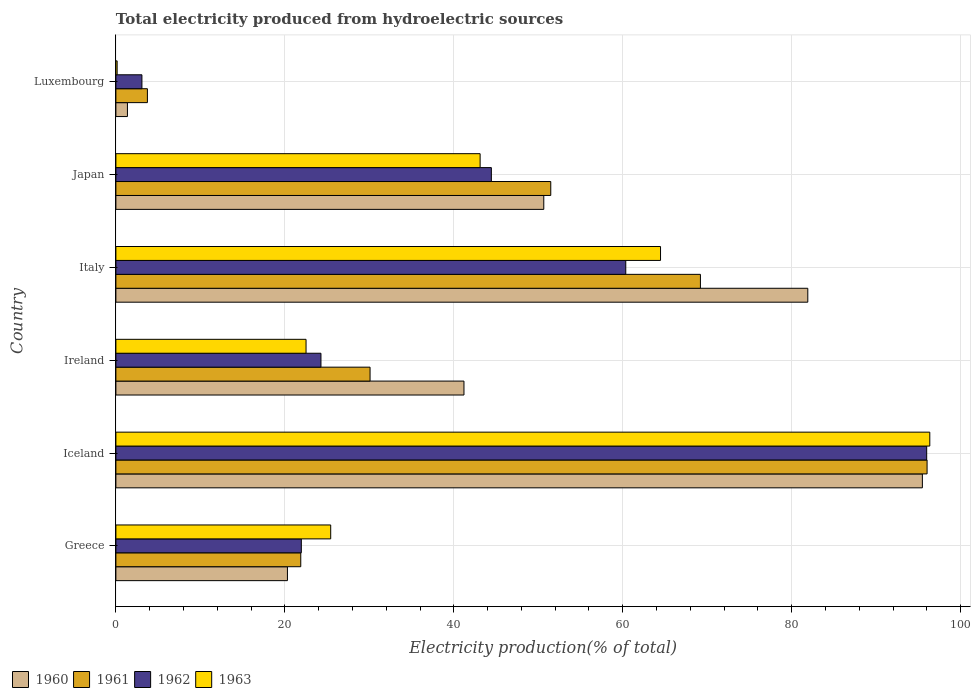How many different coloured bars are there?
Provide a succinct answer. 4. How many groups of bars are there?
Offer a terse response. 6. Are the number of bars per tick equal to the number of legend labels?
Keep it short and to the point. Yes. How many bars are there on the 1st tick from the bottom?
Provide a short and direct response. 4. What is the total electricity produced in 1961 in Iceland?
Your answer should be compact. 96.02. Across all countries, what is the maximum total electricity produced in 1961?
Your answer should be very brief. 96.02. Across all countries, what is the minimum total electricity produced in 1963?
Keep it short and to the point. 0.15. In which country was the total electricity produced in 1963 maximum?
Your response must be concise. Iceland. In which country was the total electricity produced in 1962 minimum?
Your response must be concise. Luxembourg. What is the total total electricity produced in 1960 in the graph?
Offer a terse response. 290.89. What is the difference between the total electricity produced in 1963 in Iceland and that in Ireland?
Ensure brevity in your answer.  73.83. What is the difference between the total electricity produced in 1961 in Ireland and the total electricity produced in 1963 in Greece?
Offer a terse response. 4.66. What is the average total electricity produced in 1963 per country?
Your answer should be compact. 42. What is the difference between the total electricity produced in 1963 and total electricity produced in 1960 in Luxembourg?
Ensure brevity in your answer.  -1.22. What is the ratio of the total electricity produced in 1963 in Greece to that in Iceland?
Offer a very short reply. 0.26. Is the difference between the total electricity produced in 1963 in Greece and Italy greater than the difference between the total electricity produced in 1960 in Greece and Italy?
Provide a succinct answer. Yes. What is the difference between the highest and the second highest total electricity produced in 1960?
Offer a very short reply. 13.56. What is the difference between the highest and the lowest total electricity produced in 1960?
Give a very brief answer. 94.1. Is the sum of the total electricity produced in 1962 in Greece and Ireland greater than the maximum total electricity produced in 1961 across all countries?
Give a very brief answer. No. Is it the case that in every country, the sum of the total electricity produced in 1963 and total electricity produced in 1962 is greater than the sum of total electricity produced in 1960 and total electricity produced in 1961?
Make the answer very short. No. Is it the case that in every country, the sum of the total electricity produced in 1962 and total electricity produced in 1960 is greater than the total electricity produced in 1963?
Make the answer very short. Yes. Are all the bars in the graph horizontal?
Provide a succinct answer. Yes. How many countries are there in the graph?
Your answer should be compact. 6. What is the difference between two consecutive major ticks on the X-axis?
Provide a short and direct response. 20. Does the graph contain any zero values?
Keep it short and to the point. No. How are the legend labels stacked?
Ensure brevity in your answer.  Horizontal. What is the title of the graph?
Offer a terse response. Total electricity produced from hydroelectric sources. What is the label or title of the X-axis?
Offer a very short reply. Electricity production(% of total). What is the Electricity production(% of total) in 1960 in Greece?
Give a very brief answer. 20.31. What is the Electricity production(% of total) in 1961 in Greece?
Provide a succinct answer. 21.88. What is the Electricity production(% of total) of 1962 in Greece?
Offer a terse response. 21.95. What is the Electricity production(% of total) in 1963 in Greece?
Ensure brevity in your answer.  25.43. What is the Electricity production(% of total) in 1960 in Iceland?
Make the answer very short. 95.46. What is the Electricity production(% of total) in 1961 in Iceland?
Make the answer very short. 96.02. What is the Electricity production(% of total) in 1962 in Iceland?
Give a very brief answer. 95.97. What is the Electricity production(% of total) in 1963 in Iceland?
Your response must be concise. 96.34. What is the Electricity production(% of total) of 1960 in Ireland?
Offer a very short reply. 41.2. What is the Electricity production(% of total) of 1961 in Ireland?
Ensure brevity in your answer.  30.09. What is the Electricity production(% of total) of 1962 in Ireland?
Give a very brief answer. 24.27. What is the Electricity production(% of total) in 1963 in Ireland?
Provide a succinct answer. 22.51. What is the Electricity production(% of total) in 1960 in Italy?
Your answer should be compact. 81.9. What is the Electricity production(% of total) of 1961 in Italy?
Provide a short and direct response. 69.19. What is the Electricity production(% of total) of 1962 in Italy?
Offer a terse response. 60.35. What is the Electricity production(% of total) of 1963 in Italy?
Offer a terse response. 64.47. What is the Electricity production(% of total) of 1960 in Japan?
Your answer should be compact. 50.65. What is the Electricity production(% of total) of 1961 in Japan?
Your answer should be very brief. 51.48. What is the Electricity production(% of total) in 1962 in Japan?
Give a very brief answer. 44.44. What is the Electricity production(% of total) of 1963 in Japan?
Your response must be concise. 43.11. What is the Electricity production(% of total) in 1960 in Luxembourg?
Give a very brief answer. 1.37. What is the Electricity production(% of total) of 1961 in Luxembourg?
Give a very brief answer. 3.73. What is the Electricity production(% of total) of 1962 in Luxembourg?
Make the answer very short. 3.08. What is the Electricity production(% of total) in 1963 in Luxembourg?
Make the answer very short. 0.15. Across all countries, what is the maximum Electricity production(% of total) in 1960?
Provide a succinct answer. 95.46. Across all countries, what is the maximum Electricity production(% of total) in 1961?
Make the answer very short. 96.02. Across all countries, what is the maximum Electricity production(% of total) in 1962?
Your answer should be compact. 95.97. Across all countries, what is the maximum Electricity production(% of total) in 1963?
Your answer should be very brief. 96.34. Across all countries, what is the minimum Electricity production(% of total) of 1960?
Make the answer very short. 1.37. Across all countries, what is the minimum Electricity production(% of total) of 1961?
Give a very brief answer. 3.73. Across all countries, what is the minimum Electricity production(% of total) in 1962?
Your answer should be compact. 3.08. Across all countries, what is the minimum Electricity production(% of total) in 1963?
Provide a succinct answer. 0.15. What is the total Electricity production(% of total) in 1960 in the graph?
Provide a succinct answer. 290.89. What is the total Electricity production(% of total) of 1961 in the graph?
Keep it short and to the point. 272.39. What is the total Electricity production(% of total) in 1962 in the graph?
Provide a short and direct response. 250.08. What is the total Electricity production(% of total) of 1963 in the graph?
Give a very brief answer. 252.01. What is the difference between the Electricity production(% of total) of 1960 in Greece and that in Iceland?
Keep it short and to the point. -75.16. What is the difference between the Electricity production(% of total) in 1961 in Greece and that in Iceland?
Your response must be concise. -74.14. What is the difference between the Electricity production(% of total) of 1962 in Greece and that in Iceland?
Offer a very short reply. -74.02. What is the difference between the Electricity production(% of total) in 1963 in Greece and that in Iceland?
Your response must be concise. -70.91. What is the difference between the Electricity production(% of total) of 1960 in Greece and that in Ireland?
Keep it short and to the point. -20.9. What is the difference between the Electricity production(% of total) of 1961 in Greece and that in Ireland?
Your answer should be very brief. -8.2. What is the difference between the Electricity production(% of total) of 1962 in Greece and that in Ireland?
Make the answer very short. -2.32. What is the difference between the Electricity production(% of total) of 1963 in Greece and that in Ireland?
Provide a short and direct response. 2.92. What is the difference between the Electricity production(% of total) of 1960 in Greece and that in Italy?
Offer a very short reply. -61.59. What is the difference between the Electricity production(% of total) of 1961 in Greece and that in Italy?
Your answer should be very brief. -47.31. What is the difference between the Electricity production(% of total) in 1962 in Greece and that in Italy?
Keep it short and to the point. -38.4. What is the difference between the Electricity production(% of total) of 1963 in Greece and that in Italy?
Ensure brevity in your answer.  -39.04. What is the difference between the Electricity production(% of total) in 1960 in Greece and that in Japan?
Offer a very short reply. -30.34. What is the difference between the Electricity production(% of total) in 1961 in Greece and that in Japan?
Offer a very short reply. -29.59. What is the difference between the Electricity production(% of total) in 1962 in Greece and that in Japan?
Keep it short and to the point. -22.49. What is the difference between the Electricity production(% of total) in 1963 in Greece and that in Japan?
Give a very brief answer. -17.69. What is the difference between the Electricity production(% of total) of 1960 in Greece and that in Luxembourg?
Offer a very short reply. 18.94. What is the difference between the Electricity production(% of total) of 1961 in Greece and that in Luxembourg?
Your answer should be very brief. 18.15. What is the difference between the Electricity production(% of total) of 1962 in Greece and that in Luxembourg?
Your answer should be very brief. 18.87. What is the difference between the Electricity production(% of total) of 1963 in Greece and that in Luxembourg?
Provide a short and direct response. 25.28. What is the difference between the Electricity production(% of total) of 1960 in Iceland and that in Ireland?
Your answer should be very brief. 54.26. What is the difference between the Electricity production(% of total) in 1961 in Iceland and that in Ireland?
Your answer should be compact. 65.93. What is the difference between the Electricity production(% of total) in 1962 in Iceland and that in Ireland?
Offer a terse response. 71.7. What is the difference between the Electricity production(% of total) in 1963 in Iceland and that in Ireland?
Your response must be concise. 73.83. What is the difference between the Electricity production(% of total) of 1960 in Iceland and that in Italy?
Your answer should be very brief. 13.56. What is the difference between the Electricity production(% of total) of 1961 in Iceland and that in Italy?
Ensure brevity in your answer.  26.83. What is the difference between the Electricity production(% of total) in 1962 in Iceland and that in Italy?
Your answer should be very brief. 35.62. What is the difference between the Electricity production(% of total) of 1963 in Iceland and that in Italy?
Offer a terse response. 31.87. What is the difference between the Electricity production(% of total) of 1960 in Iceland and that in Japan?
Give a very brief answer. 44.81. What is the difference between the Electricity production(% of total) in 1961 in Iceland and that in Japan?
Offer a terse response. 44.54. What is the difference between the Electricity production(% of total) in 1962 in Iceland and that in Japan?
Your answer should be very brief. 51.53. What is the difference between the Electricity production(% of total) in 1963 in Iceland and that in Japan?
Offer a very short reply. 53.23. What is the difference between the Electricity production(% of total) in 1960 in Iceland and that in Luxembourg?
Offer a very short reply. 94.1. What is the difference between the Electricity production(% of total) in 1961 in Iceland and that in Luxembourg?
Keep it short and to the point. 92.29. What is the difference between the Electricity production(% of total) in 1962 in Iceland and that in Luxembourg?
Offer a very short reply. 92.89. What is the difference between the Electricity production(% of total) of 1963 in Iceland and that in Luxembourg?
Keep it short and to the point. 96.19. What is the difference between the Electricity production(% of total) of 1960 in Ireland and that in Italy?
Keep it short and to the point. -40.7. What is the difference between the Electricity production(% of total) of 1961 in Ireland and that in Italy?
Your answer should be very brief. -39.1. What is the difference between the Electricity production(% of total) of 1962 in Ireland and that in Italy?
Ensure brevity in your answer.  -36.08. What is the difference between the Electricity production(% of total) in 1963 in Ireland and that in Italy?
Your answer should be compact. -41.96. What is the difference between the Electricity production(% of total) of 1960 in Ireland and that in Japan?
Your response must be concise. -9.45. What is the difference between the Electricity production(% of total) of 1961 in Ireland and that in Japan?
Keep it short and to the point. -21.39. What is the difference between the Electricity production(% of total) in 1962 in Ireland and that in Japan?
Your response must be concise. -20.17. What is the difference between the Electricity production(% of total) of 1963 in Ireland and that in Japan?
Provide a succinct answer. -20.61. What is the difference between the Electricity production(% of total) of 1960 in Ireland and that in Luxembourg?
Offer a terse response. 39.84. What is the difference between the Electricity production(% of total) in 1961 in Ireland and that in Luxembourg?
Make the answer very short. 26.36. What is the difference between the Electricity production(% of total) of 1962 in Ireland and that in Luxembourg?
Offer a terse response. 21.19. What is the difference between the Electricity production(% of total) of 1963 in Ireland and that in Luxembourg?
Give a very brief answer. 22.36. What is the difference between the Electricity production(% of total) in 1960 in Italy and that in Japan?
Offer a very short reply. 31.25. What is the difference between the Electricity production(% of total) in 1961 in Italy and that in Japan?
Offer a terse response. 17.71. What is the difference between the Electricity production(% of total) in 1962 in Italy and that in Japan?
Provide a short and direct response. 15.91. What is the difference between the Electricity production(% of total) in 1963 in Italy and that in Japan?
Offer a very short reply. 21.35. What is the difference between the Electricity production(% of total) in 1960 in Italy and that in Luxembourg?
Offer a very short reply. 80.53. What is the difference between the Electricity production(% of total) in 1961 in Italy and that in Luxembourg?
Your answer should be very brief. 65.46. What is the difference between the Electricity production(% of total) in 1962 in Italy and that in Luxembourg?
Make the answer very short. 57.27. What is the difference between the Electricity production(% of total) of 1963 in Italy and that in Luxembourg?
Provide a succinct answer. 64.32. What is the difference between the Electricity production(% of total) of 1960 in Japan and that in Luxembourg?
Offer a terse response. 49.28. What is the difference between the Electricity production(% of total) of 1961 in Japan and that in Luxembourg?
Provide a short and direct response. 47.75. What is the difference between the Electricity production(% of total) of 1962 in Japan and that in Luxembourg?
Offer a very short reply. 41.36. What is the difference between the Electricity production(% of total) of 1963 in Japan and that in Luxembourg?
Provide a succinct answer. 42.97. What is the difference between the Electricity production(% of total) in 1960 in Greece and the Electricity production(% of total) in 1961 in Iceland?
Offer a terse response. -75.71. What is the difference between the Electricity production(% of total) in 1960 in Greece and the Electricity production(% of total) in 1962 in Iceland?
Ensure brevity in your answer.  -75.67. What is the difference between the Electricity production(% of total) of 1960 in Greece and the Electricity production(% of total) of 1963 in Iceland?
Offer a terse response. -76.04. What is the difference between the Electricity production(% of total) of 1961 in Greece and the Electricity production(% of total) of 1962 in Iceland?
Offer a very short reply. -74.09. What is the difference between the Electricity production(% of total) of 1961 in Greece and the Electricity production(% of total) of 1963 in Iceland?
Your answer should be very brief. -74.46. What is the difference between the Electricity production(% of total) of 1962 in Greece and the Electricity production(% of total) of 1963 in Iceland?
Your answer should be compact. -74.39. What is the difference between the Electricity production(% of total) in 1960 in Greece and the Electricity production(% of total) in 1961 in Ireland?
Provide a succinct answer. -9.78. What is the difference between the Electricity production(% of total) in 1960 in Greece and the Electricity production(% of total) in 1962 in Ireland?
Ensure brevity in your answer.  -3.97. What is the difference between the Electricity production(% of total) in 1960 in Greece and the Electricity production(% of total) in 1963 in Ireland?
Keep it short and to the point. -2.2. What is the difference between the Electricity production(% of total) of 1961 in Greece and the Electricity production(% of total) of 1962 in Ireland?
Ensure brevity in your answer.  -2.39. What is the difference between the Electricity production(% of total) in 1961 in Greece and the Electricity production(% of total) in 1963 in Ireland?
Give a very brief answer. -0.63. What is the difference between the Electricity production(% of total) in 1962 in Greece and the Electricity production(% of total) in 1963 in Ireland?
Keep it short and to the point. -0.56. What is the difference between the Electricity production(% of total) in 1960 in Greece and the Electricity production(% of total) in 1961 in Italy?
Your answer should be compact. -48.88. What is the difference between the Electricity production(% of total) of 1960 in Greece and the Electricity production(% of total) of 1962 in Italy?
Ensure brevity in your answer.  -40.05. What is the difference between the Electricity production(% of total) in 1960 in Greece and the Electricity production(% of total) in 1963 in Italy?
Offer a terse response. -44.16. What is the difference between the Electricity production(% of total) in 1961 in Greece and the Electricity production(% of total) in 1962 in Italy?
Your answer should be very brief. -38.47. What is the difference between the Electricity production(% of total) in 1961 in Greece and the Electricity production(% of total) in 1963 in Italy?
Your response must be concise. -42.58. What is the difference between the Electricity production(% of total) in 1962 in Greece and the Electricity production(% of total) in 1963 in Italy?
Keep it short and to the point. -42.52. What is the difference between the Electricity production(% of total) of 1960 in Greece and the Electricity production(% of total) of 1961 in Japan?
Your answer should be compact. -31.17. What is the difference between the Electricity production(% of total) in 1960 in Greece and the Electricity production(% of total) in 1962 in Japan?
Your answer should be very brief. -24.14. What is the difference between the Electricity production(% of total) in 1960 in Greece and the Electricity production(% of total) in 1963 in Japan?
Your answer should be compact. -22.81. What is the difference between the Electricity production(% of total) of 1961 in Greece and the Electricity production(% of total) of 1962 in Japan?
Your response must be concise. -22.56. What is the difference between the Electricity production(% of total) in 1961 in Greece and the Electricity production(% of total) in 1963 in Japan?
Provide a succinct answer. -21.23. What is the difference between the Electricity production(% of total) in 1962 in Greece and the Electricity production(% of total) in 1963 in Japan?
Keep it short and to the point. -21.16. What is the difference between the Electricity production(% of total) of 1960 in Greece and the Electricity production(% of total) of 1961 in Luxembourg?
Ensure brevity in your answer.  16.58. What is the difference between the Electricity production(% of total) of 1960 in Greece and the Electricity production(% of total) of 1962 in Luxembourg?
Give a very brief answer. 17.22. What is the difference between the Electricity production(% of total) of 1960 in Greece and the Electricity production(% of total) of 1963 in Luxembourg?
Offer a terse response. 20.16. What is the difference between the Electricity production(% of total) of 1961 in Greece and the Electricity production(% of total) of 1962 in Luxembourg?
Keep it short and to the point. 18.8. What is the difference between the Electricity production(% of total) in 1961 in Greece and the Electricity production(% of total) in 1963 in Luxembourg?
Make the answer very short. 21.74. What is the difference between the Electricity production(% of total) of 1962 in Greece and the Electricity production(% of total) of 1963 in Luxembourg?
Ensure brevity in your answer.  21.8. What is the difference between the Electricity production(% of total) of 1960 in Iceland and the Electricity production(% of total) of 1961 in Ireland?
Keep it short and to the point. 65.38. What is the difference between the Electricity production(% of total) in 1960 in Iceland and the Electricity production(% of total) in 1962 in Ireland?
Keep it short and to the point. 71.19. What is the difference between the Electricity production(% of total) of 1960 in Iceland and the Electricity production(% of total) of 1963 in Ireland?
Your response must be concise. 72.95. What is the difference between the Electricity production(% of total) of 1961 in Iceland and the Electricity production(% of total) of 1962 in Ireland?
Offer a terse response. 71.75. What is the difference between the Electricity production(% of total) of 1961 in Iceland and the Electricity production(% of total) of 1963 in Ireland?
Make the answer very short. 73.51. What is the difference between the Electricity production(% of total) in 1962 in Iceland and the Electricity production(% of total) in 1963 in Ireland?
Offer a very short reply. 73.47. What is the difference between the Electricity production(% of total) of 1960 in Iceland and the Electricity production(% of total) of 1961 in Italy?
Make the answer very short. 26.27. What is the difference between the Electricity production(% of total) of 1960 in Iceland and the Electricity production(% of total) of 1962 in Italy?
Ensure brevity in your answer.  35.11. What is the difference between the Electricity production(% of total) in 1960 in Iceland and the Electricity production(% of total) in 1963 in Italy?
Provide a short and direct response. 30.99. What is the difference between the Electricity production(% of total) in 1961 in Iceland and the Electricity production(% of total) in 1962 in Italy?
Make the answer very short. 35.67. What is the difference between the Electricity production(% of total) in 1961 in Iceland and the Electricity production(% of total) in 1963 in Italy?
Provide a succinct answer. 31.55. What is the difference between the Electricity production(% of total) in 1962 in Iceland and the Electricity production(% of total) in 1963 in Italy?
Offer a terse response. 31.51. What is the difference between the Electricity production(% of total) of 1960 in Iceland and the Electricity production(% of total) of 1961 in Japan?
Your response must be concise. 43.99. What is the difference between the Electricity production(% of total) of 1960 in Iceland and the Electricity production(% of total) of 1962 in Japan?
Your response must be concise. 51.02. What is the difference between the Electricity production(% of total) in 1960 in Iceland and the Electricity production(% of total) in 1963 in Japan?
Ensure brevity in your answer.  52.35. What is the difference between the Electricity production(% of total) of 1961 in Iceland and the Electricity production(% of total) of 1962 in Japan?
Provide a succinct answer. 51.58. What is the difference between the Electricity production(% of total) in 1961 in Iceland and the Electricity production(% of total) in 1963 in Japan?
Your answer should be very brief. 52.91. What is the difference between the Electricity production(% of total) of 1962 in Iceland and the Electricity production(% of total) of 1963 in Japan?
Your response must be concise. 52.86. What is the difference between the Electricity production(% of total) in 1960 in Iceland and the Electricity production(% of total) in 1961 in Luxembourg?
Your answer should be compact. 91.73. What is the difference between the Electricity production(% of total) in 1960 in Iceland and the Electricity production(% of total) in 1962 in Luxembourg?
Provide a short and direct response. 92.38. What is the difference between the Electricity production(% of total) in 1960 in Iceland and the Electricity production(% of total) in 1963 in Luxembourg?
Give a very brief answer. 95.32. What is the difference between the Electricity production(% of total) of 1961 in Iceland and the Electricity production(% of total) of 1962 in Luxembourg?
Offer a terse response. 92.94. What is the difference between the Electricity production(% of total) of 1961 in Iceland and the Electricity production(% of total) of 1963 in Luxembourg?
Provide a succinct answer. 95.87. What is the difference between the Electricity production(% of total) of 1962 in Iceland and the Electricity production(% of total) of 1963 in Luxembourg?
Give a very brief answer. 95.83. What is the difference between the Electricity production(% of total) of 1960 in Ireland and the Electricity production(% of total) of 1961 in Italy?
Make the answer very short. -27.99. What is the difference between the Electricity production(% of total) in 1960 in Ireland and the Electricity production(% of total) in 1962 in Italy?
Provide a short and direct response. -19.15. What is the difference between the Electricity production(% of total) of 1960 in Ireland and the Electricity production(% of total) of 1963 in Italy?
Your response must be concise. -23.27. What is the difference between the Electricity production(% of total) in 1961 in Ireland and the Electricity production(% of total) in 1962 in Italy?
Keep it short and to the point. -30.27. What is the difference between the Electricity production(% of total) in 1961 in Ireland and the Electricity production(% of total) in 1963 in Italy?
Give a very brief answer. -34.38. What is the difference between the Electricity production(% of total) in 1962 in Ireland and the Electricity production(% of total) in 1963 in Italy?
Provide a succinct answer. -40.2. What is the difference between the Electricity production(% of total) of 1960 in Ireland and the Electricity production(% of total) of 1961 in Japan?
Your answer should be compact. -10.27. What is the difference between the Electricity production(% of total) of 1960 in Ireland and the Electricity production(% of total) of 1962 in Japan?
Your answer should be very brief. -3.24. What is the difference between the Electricity production(% of total) of 1960 in Ireland and the Electricity production(% of total) of 1963 in Japan?
Keep it short and to the point. -1.91. What is the difference between the Electricity production(% of total) in 1961 in Ireland and the Electricity production(% of total) in 1962 in Japan?
Provide a short and direct response. -14.36. What is the difference between the Electricity production(% of total) in 1961 in Ireland and the Electricity production(% of total) in 1963 in Japan?
Offer a very short reply. -13.03. What is the difference between the Electricity production(% of total) in 1962 in Ireland and the Electricity production(% of total) in 1963 in Japan?
Ensure brevity in your answer.  -18.84. What is the difference between the Electricity production(% of total) in 1960 in Ireland and the Electricity production(% of total) in 1961 in Luxembourg?
Offer a terse response. 37.47. What is the difference between the Electricity production(% of total) in 1960 in Ireland and the Electricity production(% of total) in 1962 in Luxembourg?
Your answer should be compact. 38.12. What is the difference between the Electricity production(% of total) in 1960 in Ireland and the Electricity production(% of total) in 1963 in Luxembourg?
Your answer should be very brief. 41.05. What is the difference between the Electricity production(% of total) in 1961 in Ireland and the Electricity production(% of total) in 1962 in Luxembourg?
Keep it short and to the point. 27. What is the difference between the Electricity production(% of total) of 1961 in Ireland and the Electricity production(% of total) of 1963 in Luxembourg?
Provide a succinct answer. 29.94. What is the difference between the Electricity production(% of total) of 1962 in Ireland and the Electricity production(% of total) of 1963 in Luxembourg?
Your response must be concise. 24.12. What is the difference between the Electricity production(% of total) of 1960 in Italy and the Electricity production(% of total) of 1961 in Japan?
Provide a short and direct response. 30.42. What is the difference between the Electricity production(% of total) of 1960 in Italy and the Electricity production(% of total) of 1962 in Japan?
Offer a terse response. 37.46. What is the difference between the Electricity production(% of total) of 1960 in Italy and the Electricity production(% of total) of 1963 in Japan?
Make the answer very short. 38.79. What is the difference between the Electricity production(% of total) of 1961 in Italy and the Electricity production(% of total) of 1962 in Japan?
Ensure brevity in your answer.  24.75. What is the difference between the Electricity production(% of total) in 1961 in Italy and the Electricity production(% of total) in 1963 in Japan?
Your response must be concise. 26.08. What is the difference between the Electricity production(% of total) of 1962 in Italy and the Electricity production(% of total) of 1963 in Japan?
Your answer should be compact. 17.24. What is the difference between the Electricity production(% of total) in 1960 in Italy and the Electricity production(% of total) in 1961 in Luxembourg?
Ensure brevity in your answer.  78.17. What is the difference between the Electricity production(% of total) in 1960 in Italy and the Electricity production(% of total) in 1962 in Luxembourg?
Offer a very short reply. 78.82. What is the difference between the Electricity production(% of total) of 1960 in Italy and the Electricity production(% of total) of 1963 in Luxembourg?
Offer a very short reply. 81.75. What is the difference between the Electricity production(% of total) in 1961 in Italy and the Electricity production(% of total) in 1962 in Luxembourg?
Your response must be concise. 66.11. What is the difference between the Electricity production(% of total) in 1961 in Italy and the Electricity production(% of total) in 1963 in Luxembourg?
Provide a short and direct response. 69.04. What is the difference between the Electricity production(% of total) of 1962 in Italy and the Electricity production(% of total) of 1963 in Luxembourg?
Provide a succinct answer. 60.21. What is the difference between the Electricity production(% of total) of 1960 in Japan and the Electricity production(% of total) of 1961 in Luxembourg?
Make the answer very short. 46.92. What is the difference between the Electricity production(% of total) of 1960 in Japan and the Electricity production(% of total) of 1962 in Luxembourg?
Your answer should be compact. 47.57. What is the difference between the Electricity production(% of total) in 1960 in Japan and the Electricity production(% of total) in 1963 in Luxembourg?
Offer a very short reply. 50.5. What is the difference between the Electricity production(% of total) of 1961 in Japan and the Electricity production(% of total) of 1962 in Luxembourg?
Provide a succinct answer. 48.39. What is the difference between the Electricity production(% of total) of 1961 in Japan and the Electricity production(% of total) of 1963 in Luxembourg?
Give a very brief answer. 51.33. What is the difference between the Electricity production(% of total) of 1962 in Japan and the Electricity production(% of total) of 1963 in Luxembourg?
Your response must be concise. 44.3. What is the average Electricity production(% of total) in 1960 per country?
Offer a very short reply. 48.48. What is the average Electricity production(% of total) in 1961 per country?
Offer a terse response. 45.4. What is the average Electricity production(% of total) in 1962 per country?
Provide a short and direct response. 41.68. What is the average Electricity production(% of total) in 1963 per country?
Provide a short and direct response. 42. What is the difference between the Electricity production(% of total) of 1960 and Electricity production(% of total) of 1961 in Greece?
Keep it short and to the point. -1.58. What is the difference between the Electricity production(% of total) of 1960 and Electricity production(% of total) of 1962 in Greece?
Provide a succinct answer. -1.64. What is the difference between the Electricity production(% of total) in 1960 and Electricity production(% of total) in 1963 in Greece?
Your response must be concise. -5.12. What is the difference between the Electricity production(% of total) of 1961 and Electricity production(% of total) of 1962 in Greece?
Provide a short and direct response. -0.07. What is the difference between the Electricity production(% of total) of 1961 and Electricity production(% of total) of 1963 in Greece?
Provide a short and direct response. -3.54. What is the difference between the Electricity production(% of total) in 1962 and Electricity production(% of total) in 1963 in Greece?
Make the answer very short. -3.48. What is the difference between the Electricity production(% of total) of 1960 and Electricity production(% of total) of 1961 in Iceland?
Your response must be concise. -0.56. What is the difference between the Electricity production(% of total) in 1960 and Electricity production(% of total) in 1962 in Iceland?
Ensure brevity in your answer.  -0.51. What is the difference between the Electricity production(% of total) of 1960 and Electricity production(% of total) of 1963 in Iceland?
Provide a succinct answer. -0.88. What is the difference between the Electricity production(% of total) in 1961 and Electricity production(% of total) in 1962 in Iceland?
Make the answer very short. 0.05. What is the difference between the Electricity production(% of total) in 1961 and Electricity production(% of total) in 1963 in Iceland?
Your response must be concise. -0.32. What is the difference between the Electricity production(% of total) in 1962 and Electricity production(% of total) in 1963 in Iceland?
Your response must be concise. -0.37. What is the difference between the Electricity production(% of total) in 1960 and Electricity production(% of total) in 1961 in Ireland?
Your answer should be compact. 11.12. What is the difference between the Electricity production(% of total) in 1960 and Electricity production(% of total) in 1962 in Ireland?
Your response must be concise. 16.93. What is the difference between the Electricity production(% of total) of 1960 and Electricity production(% of total) of 1963 in Ireland?
Provide a succinct answer. 18.69. What is the difference between the Electricity production(% of total) of 1961 and Electricity production(% of total) of 1962 in Ireland?
Ensure brevity in your answer.  5.81. What is the difference between the Electricity production(% of total) in 1961 and Electricity production(% of total) in 1963 in Ireland?
Give a very brief answer. 7.58. What is the difference between the Electricity production(% of total) of 1962 and Electricity production(% of total) of 1963 in Ireland?
Ensure brevity in your answer.  1.76. What is the difference between the Electricity production(% of total) in 1960 and Electricity production(% of total) in 1961 in Italy?
Offer a very short reply. 12.71. What is the difference between the Electricity production(% of total) in 1960 and Electricity production(% of total) in 1962 in Italy?
Your response must be concise. 21.55. What is the difference between the Electricity production(% of total) of 1960 and Electricity production(% of total) of 1963 in Italy?
Give a very brief answer. 17.43. What is the difference between the Electricity production(% of total) in 1961 and Electricity production(% of total) in 1962 in Italy?
Keep it short and to the point. 8.84. What is the difference between the Electricity production(% of total) of 1961 and Electricity production(% of total) of 1963 in Italy?
Give a very brief answer. 4.72. What is the difference between the Electricity production(% of total) of 1962 and Electricity production(% of total) of 1963 in Italy?
Your response must be concise. -4.11. What is the difference between the Electricity production(% of total) in 1960 and Electricity production(% of total) in 1961 in Japan?
Ensure brevity in your answer.  -0.83. What is the difference between the Electricity production(% of total) of 1960 and Electricity production(% of total) of 1962 in Japan?
Give a very brief answer. 6.2. What is the difference between the Electricity production(% of total) in 1960 and Electricity production(% of total) in 1963 in Japan?
Make the answer very short. 7.54. What is the difference between the Electricity production(% of total) of 1961 and Electricity production(% of total) of 1962 in Japan?
Offer a terse response. 7.03. What is the difference between the Electricity production(% of total) of 1961 and Electricity production(% of total) of 1963 in Japan?
Your response must be concise. 8.36. What is the difference between the Electricity production(% of total) in 1962 and Electricity production(% of total) in 1963 in Japan?
Provide a succinct answer. 1.33. What is the difference between the Electricity production(% of total) in 1960 and Electricity production(% of total) in 1961 in Luxembourg?
Your answer should be very brief. -2.36. What is the difference between the Electricity production(% of total) in 1960 and Electricity production(% of total) in 1962 in Luxembourg?
Your answer should be compact. -1.72. What is the difference between the Electricity production(% of total) of 1960 and Electricity production(% of total) of 1963 in Luxembourg?
Provide a succinct answer. 1.22. What is the difference between the Electricity production(% of total) of 1961 and Electricity production(% of total) of 1962 in Luxembourg?
Ensure brevity in your answer.  0.65. What is the difference between the Electricity production(% of total) of 1961 and Electricity production(% of total) of 1963 in Luxembourg?
Your response must be concise. 3.58. What is the difference between the Electricity production(% of total) in 1962 and Electricity production(% of total) in 1963 in Luxembourg?
Your response must be concise. 2.93. What is the ratio of the Electricity production(% of total) in 1960 in Greece to that in Iceland?
Give a very brief answer. 0.21. What is the ratio of the Electricity production(% of total) of 1961 in Greece to that in Iceland?
Provide a succinct answer. 0.23. What is the ratio of the Electricity production(% of total) of 1962 in Greece to that in Iceland?
Provide a succinct answer. 0.23. What is the ratio of the Electricity production(% of total) of 1963 in Greece to that in Iceland?
Ensure brevity in your answer.  0.26. What is the ratio of the Electricity production(% of total) of 1960 in Greece to that in Ireland?
Offer a terse response. 0.49. What is the ratio of the Electricity production(% of total) in 1961 in Greece to that in Ireland?
Offer a terse response. 0.73. What is the ratio of the Electricity production(% of total) in 1962 in Greece to that in Ireland?
Give a very brief answer. 0.9. What is the ratio of the Electricity production(% of total) in 1963 in Greece to that in Ireland?
Keep it short and to the point. 1.13. What is the ratio of the Electricity production(% of total) of 1960 in Greece to that in Italy?
Ensure brevity in your answer.  0.25. What is the ratio of the Electricity production(% of total) of 1961 in Greece to that in Italy?
Provide a short and direct response. 0.32. What is the ratio of the Electricity production(% of total) of 1962 in Greece to that in Italy?
Provide a succinct answer. 0.36. What is the ratio of the Electricity production(% of total) of 1963 in Greece to that in Italy?
Offer a very short reply. 0.39. What is the ratio of the Electricity production(% of total) in 1960 in Greece to that in Japan?
Your answer should be very brief. 0.4. What is the ratio of the Electricity production(% of total) of 1961 in Greece to that in Japan?
Ensure brevity in your answer.  0.43. What is the ratio of the Electricity production(% of total) of 1962 in Greece to that in Japan?
Your response must be concise. 0.49. What is the ratio of the Electricity production(% of total) of 1963 in Greece to that in Japan?
Give a very brief answer. 0.59. What is the ratio of the Electricity production(% of total) in 1960 in Greece to that in Luxembourg?
Provide a succinct answer. 14.86. What is the ratio of the Electricity production(% of total) in 1961 in Greece to that in Luxembourg?
Give a very brief answer. 5.87. What is the ratio of the Electricity production(% of total) in 1962 in Greece to that in Luxembourg?
Make the answer very short. 7.12. What is the ratio of the Electricity production(% of total) in 1963 in Greece to that in Luxembourg?
Offer a terse response. 172.27. What is the ratio of the Electricity production(% of total) in 1960 in Iceland to that in Ireland?
Ensure brevity in your answer.  2.32. What is the ratio of the Electricity production(% of total) in 1961 in Iceland to that in Ireland?
Provide a succinct answer. 3.19. What is the ratio of the Electricity production(% of total) in 1962 in Iceland to that in Ireland?
Your response must be concise. 3.95. What is the ratio of the Electricity production(% of total) in 1963 in Iceland to that in Ireland?
Provide a short and direct response. 4.28. What is the ratio of the Electricity production(% of total) in 1960 in Iceland to that in Italy?
Your response must be concise. 1.17. What is the ratio of the Electricity production(% of total) of 1961 in Iceland to that in Italy?
Make the answer very short. 1.39. What is the ratio of the Electricity production(% of total) in 1962 in Iceland to that in Italy?
Your answer should be compact. 1.59. What is the ratio of the Electricity production(% of total) of 1963 in Iceland to that in Italy?
Keep it short and to the point. 1.49. What is the ratio of the Electricity production(% of total) in 1960 in Iceland to that in Japan?
Your answer should be compact. 1.88. What is the ratio of the Electricity production(% of total) in 1961 in Iceland to that in Japan?
Provide a short and direct response. 1.87. What is the ratio of the Electricity production(% of total) in 1962 in Iceland to that in Japan?
Your answer should be compact. 2.16. What is the ratio of the Electricity production(% of total) in 1963 in Iceland to that in Japan?
Offer a very short reply. 2.23. What is the ratio of the Electricity production(% of total) in 1960 in Iceland to that in Luxembourg?
Provide a succinct answer. 69.88. What is the ratio of the Electricity production(% of total) in 1961 in Iceland to that in Luxembourg?
Offer a very short reply. 25.74. What is the ratio of the Electricity production(% of total) of 1962 in Iceland to that in Luxembourg?
Your response must be concise. 31.14. What is the ratio of the Electricity production(% of total) of 1963 in Iceland to that in Luxembourg?
Make the answer very short. 652.71. What is the ratio of the Electricity production(% of total) of 1960 in Ireland to that in Italy?
Provide a succinct answer. 0.5. What is the ratio of the Electricity production(% of total) in 1961 in Ireland to that in Italy?
Give a very brief answer. 0.43. What is the ratio of the Electricity production(% of total) in 1962 in Ireland to that in Italy?
Give a very brief answer. 0.4. What is the ratio of the Electricity production(% of total) of 1963 in Ireland to that in Italy?
Your answer should be very brief. 0.35. What is the ratio of the Electricity production(% of total) of 1960 in Ireland to that in Japan?
Offer a terse response. 0.81. What is the ratio of the Electricity production(% of total) in 1961 in Ireland to that in Japan?
Provide a short and direct response. 0.58. What is the ratio of the Electricity production(% of total) of 1962 in Ireland to that in Japan?
Keep it short and to the point. 0.55. What is the ratio of the Electricity production(% of total) in 1963 in Ireland to that in Japan?
Your answer should be compact. 0.52. What is the ratio of the Electricity production(% of total) of 1960 in Ireland to that in Luxembourg?
Provide a short and direct response. 30.16. What is the ratio of the Electricity production(% of total) of 1961 in Ireland to that in Luxembourg?
Offer a terse response. 8.07. What is the ratio of the Electricity production(% of total) of 1962 in Ireland to that in Luxembourg?
Your answer should be very brief. 7.88. What is the ratio of the Electricity production(% of total) in 1963 in Ireland to that in Luxembourg?
Offer a terse response. 152.5. What is the ratio of the Electricity production(% of total) in 1960 in Italy to that in Japan?
Ensure brevity in your answer.  1.62. What is the ratio of the Electricity production(% of total) in 1961 in Italy to that in Japan?
Offer a terse response. 1.34. What is the ratio of the Electricity production(% of total) of 1962 in Italy to that in Japan?
Your response must be concise. 1.36. What is the ratio of the Electricity production(% of total) in 1963 in Italy to that in Japan?
Your answer should be compact. 1.5. What is the ratio of the Electricity production(% of total) of 1960 in Italy to that in Luxembourg?
Keep it short and to the point. 59.95. What is the ratio of the Electricity production(% of total) of 1961 in Italy to that in Luxembourg?
Offer a very short reply. 18.55. What is the ratio of the Electricity production(% of total) in 1962 in Italy to that in Luxembourg?
Keep it short and to the point. 19.58. What is the ratio of the Electricity production(% of total) of 1963 in Italy to that in Luxembourg?
Make the answer very short. 436.77. What is the ratio of the Electricity production(% of total) in 1960 in Japan to that in Luxembourg?
Your answer should be very brief. 37.08. What is the ratio of the Electricity production(% of total) of 1961 in Japan to that in Luxembourg?
Your answer should be compact. 13.8. What is the ratio of the Electricity production(% of total) in 1962 in Japan to that in Luxembourg?
Provide a short and direct response. 14.42. What is the ratio of the Electricity production(% of total) of 1963 in Japan to that in Luxembourg?
Provide a short and direct response. 292.1. What is the difference between the highest and the second highest Electricity production(% of total) in 1960?
Offer a terse response. 13.56. What is the difference between the highest and the second highest Electricity production(% of total) in 1961?
Your answer should be compact. 26.83. What is the difference between the highest and the second highest Electricity production(% of total) of 1962?
Provide a short and direct response. 35.62. What is the difference between the highest and the second highest Electricity production(% of total) of 1963?
Make the answer very short. 31.87. What is the difference between the highest and the lowest Electricity production(% of total) of 1960?
Your answer should be compact. 94.1. What is the difference between the highest and the lowest Electricity production(% of total) in 1961?
Your response must be concise. 92.29. What is the difference between the highest and the lowest Electricity production(% of total) of 1962?
Provide a short and direct response. 92.89. What is the difference between the highest and the lowest Electricity production(% of total) in 1963?
Keep it short and to the point. 96.19. 